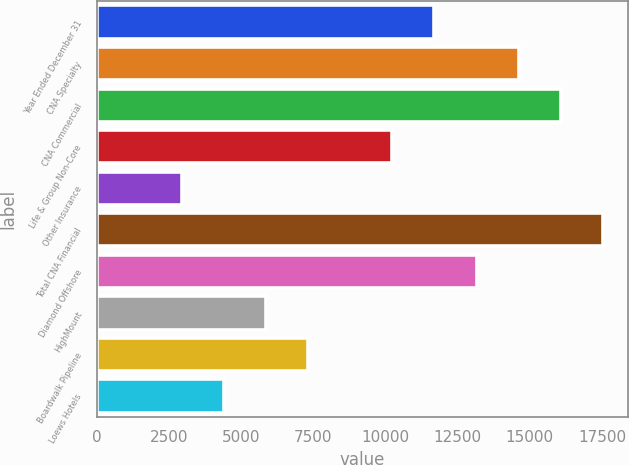<chart> <loc_0><loc_0><loc_500><loc_500><bar_chart><fcel>Year Ended December 31<fcel>CNA Specialty<fcel>CNA Commercial<fcel>Life & Group Non-Core<fcel>Other Insurance<fcel>Total CNA Financial<fcel>Diamond Offshore<fcel>HighMount<fcel>Boardwalk Pipeline<fcel>Loews Hotels<nl><fcel>11695.8<fcel>14615<fcel>16074.6<fcel>10236.2<fcel>2938.2<fcel>17534.2<fcel>13155.4<fcel>5857.4<fcel>7317<fcel>4397.8<nl></chart> 